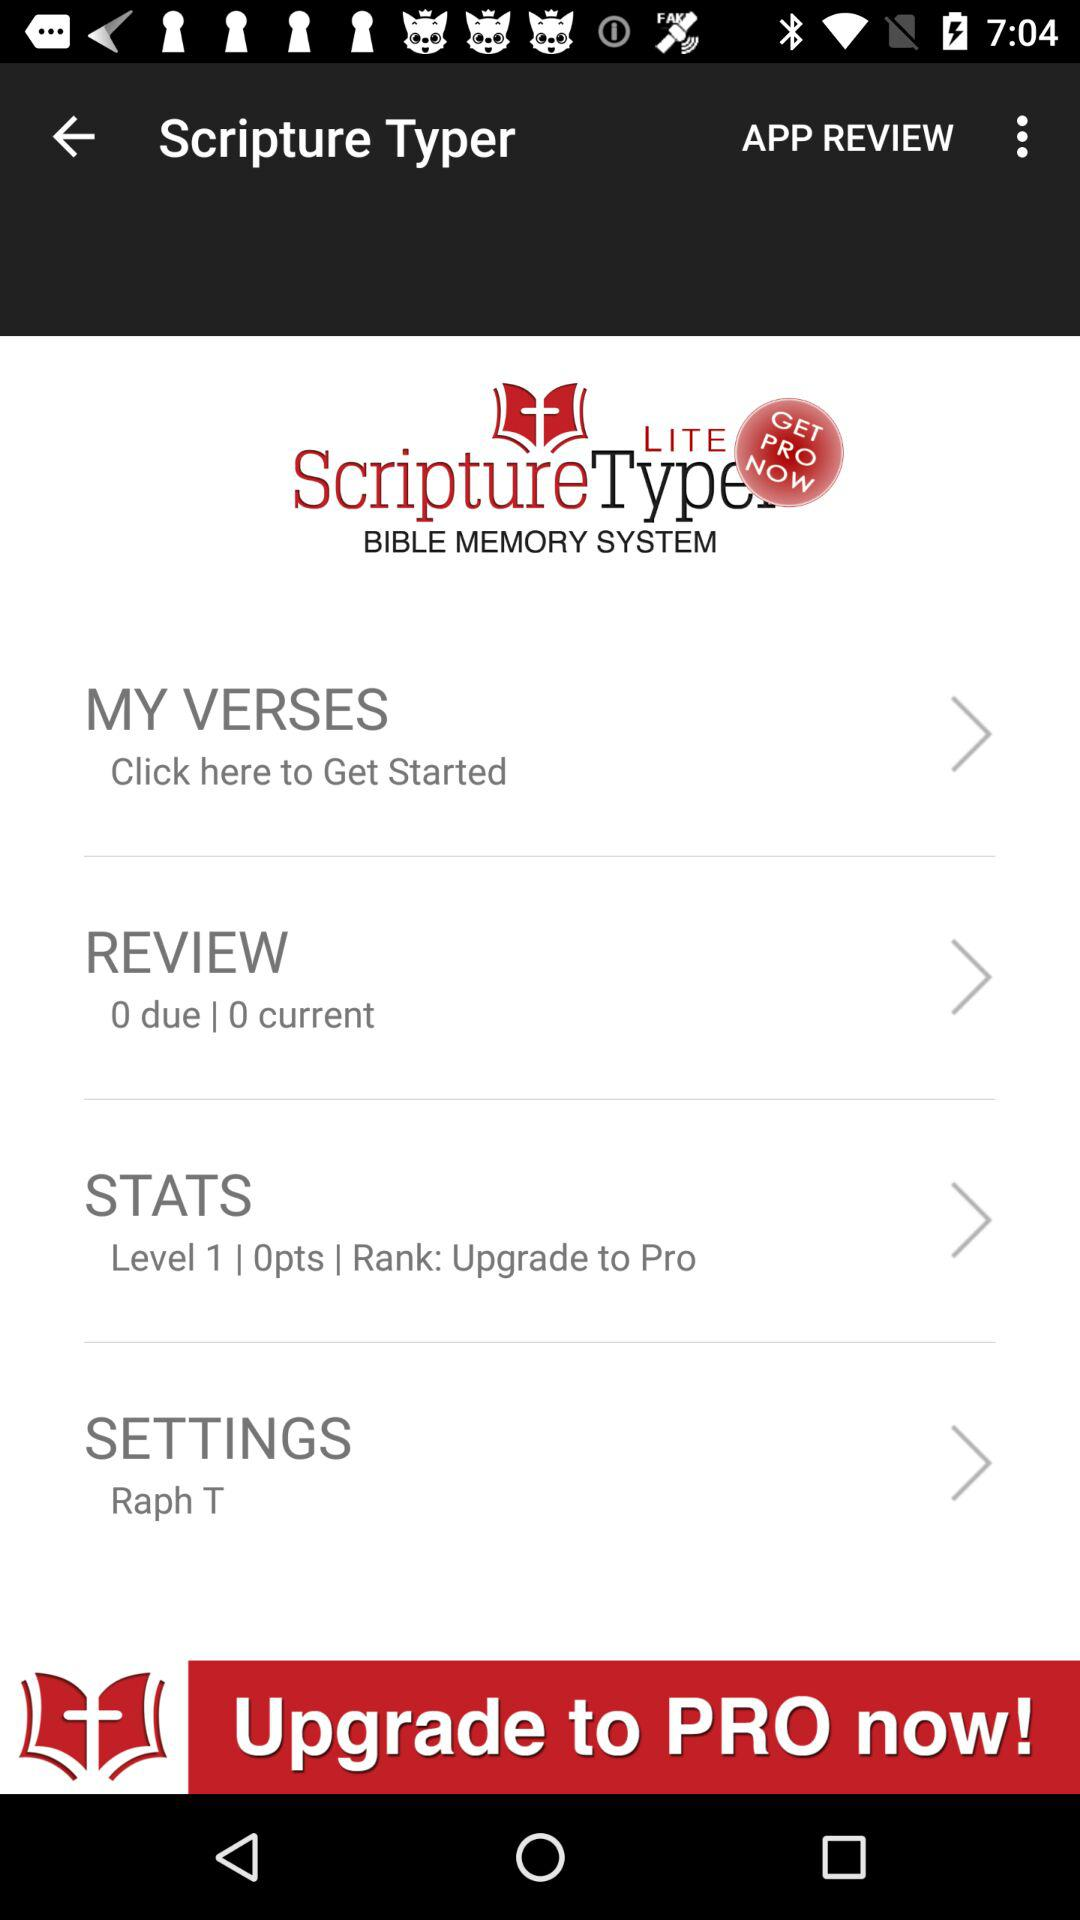What is the application name? The application name is "Scripture Typer". 